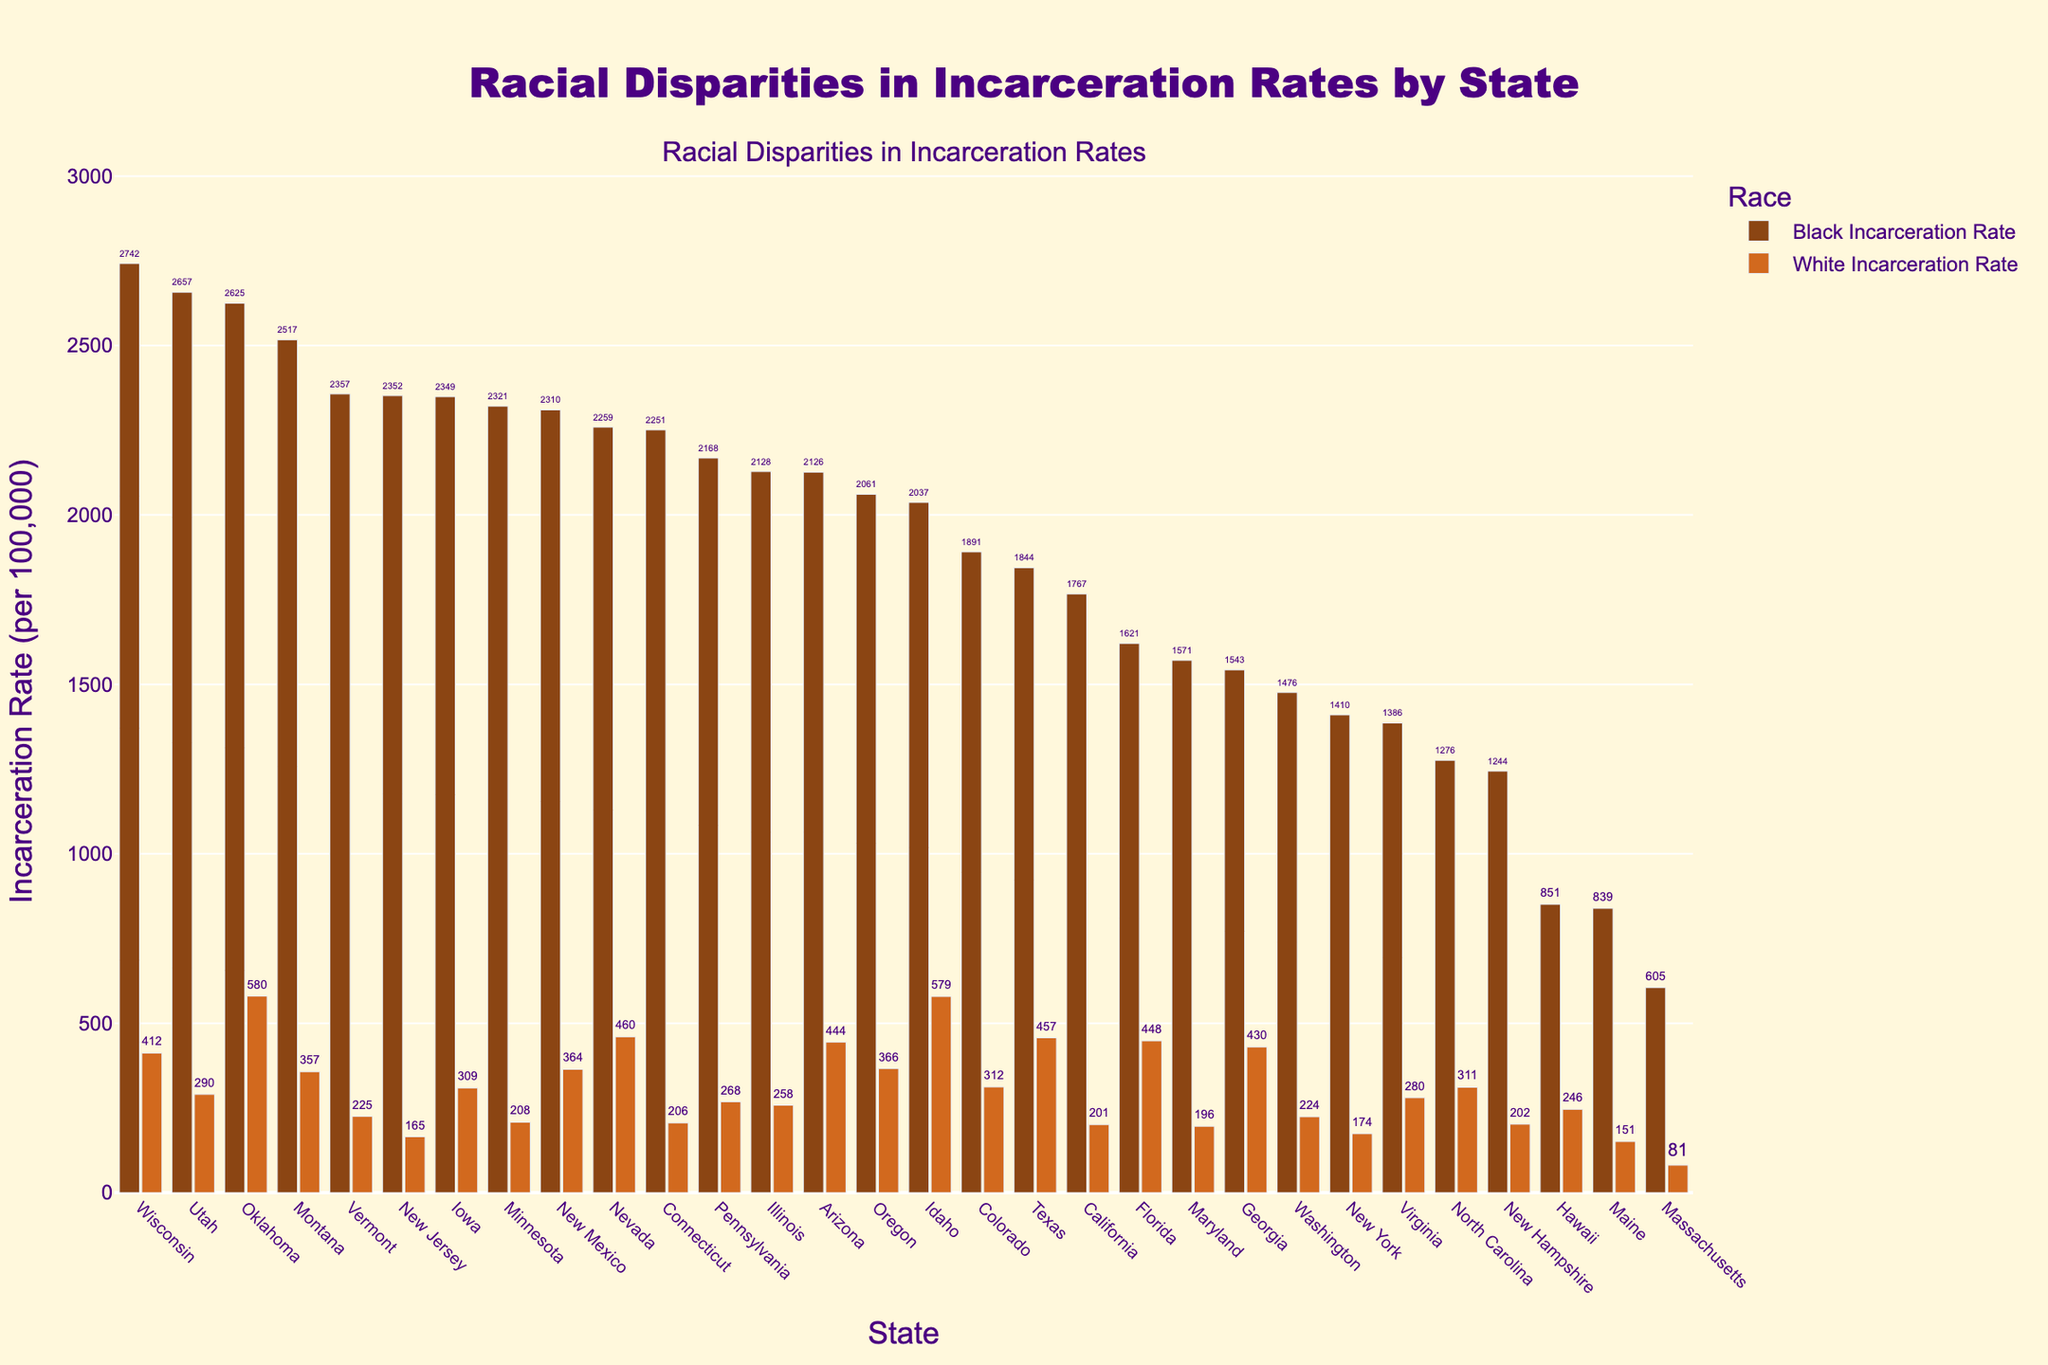Which state has the highest Black incarceration rate, and what is that rate? Wisconsin has the highest Black incarceration rate at 2742 per 100,000. This can be seen as the tallest bar for the Black Incarceration Rate category.
Answer: Wisconsin, 2742 Compare the Black and White incarceration rates in Vermont. What's the difference between them? The Black incarceration rate in Vermont is 2357 per 100,000, and the White incarceration rate is 225 per 100,000. The difference is computed as 2357 - 225.
Answer: 2132 Identify the state with the smallest gap between Black and White incarceration rates and calculate the gap. Massachusetts has the smallest gap, with Black incarceration rate at 605 and White incarceration rate at 81. Calculating the difference: 605 - 81.
Answer: Massachusetts, 524 Which state has the largest visual disparity between Black and White incarceration rates, and what is that disparity? Wisconsin shows the largest visual disparity; its Black incarceration rate is 2742, and its White incarceration rate is 412. The difference is 2742 - 412.
Answer: Wisconsin, 2330 If we were to rank the states by White incarceration rates, which state would be ranked third? Sorting the states by their White incarceration rates in descending order, Idaho has the highest at 579, Oklahoma second with 580, and Texas third with 457.
Answer: Texas What is the average White incarceration rate among the states listed? Summing up the White incarceration rates and dividing by the number of states (30): (412 + 580 + 225 + 165 + 309 + 208 + 206 + 268 + 258 + 201 + 174 + 246 + 81 + 151 + 202 + 366 + 457 + 448 + 430 + 311 + 280 + 196 + 444 + 312 + 224 + 460 + 364 + 290 + 579 + 357) = 8903, and averaging it: 8903 / 30.
Answer: 296.77 Examine California's incarceration rates for both races. How do they compare to the average rates of each race across all states? California's Black incarceration rate is 1767; the average for Black is (total Black rates/30). California's White rate is 201; the average is 296.77.
Answer: California's Black rate: below average; White rate: below average Find two states with similar White incarceration rates but divergent Black incarceration rates, and state the rates. Pennsylvania and Arizona have similar White incarceration rates (268 and 444 respectively). Their Black incarceration rates diverge significantly (2168 for Pennsylvania and 2126 for Arizona).
Answer: Pennsylvania Black: 2168, Arizona Black: 2126 What is the median Black incarceration rate for the listed states? Sorting Black incarceration rates in ascending order and finding the middle value: (605, 839, 851, 1244, 1276, 1386, 1410, 1543, 1571, 1621, 1767, 1844, 1891, 2037, 2061, 2126, 2128, 2168, 2251, 2259, 2310, 2321, 2349, 2352, 2357, 2517, 2625, 2657, 2742); the median is the middle value in this sequence.
Answer: 2074 (average of 2037 and 2117) 